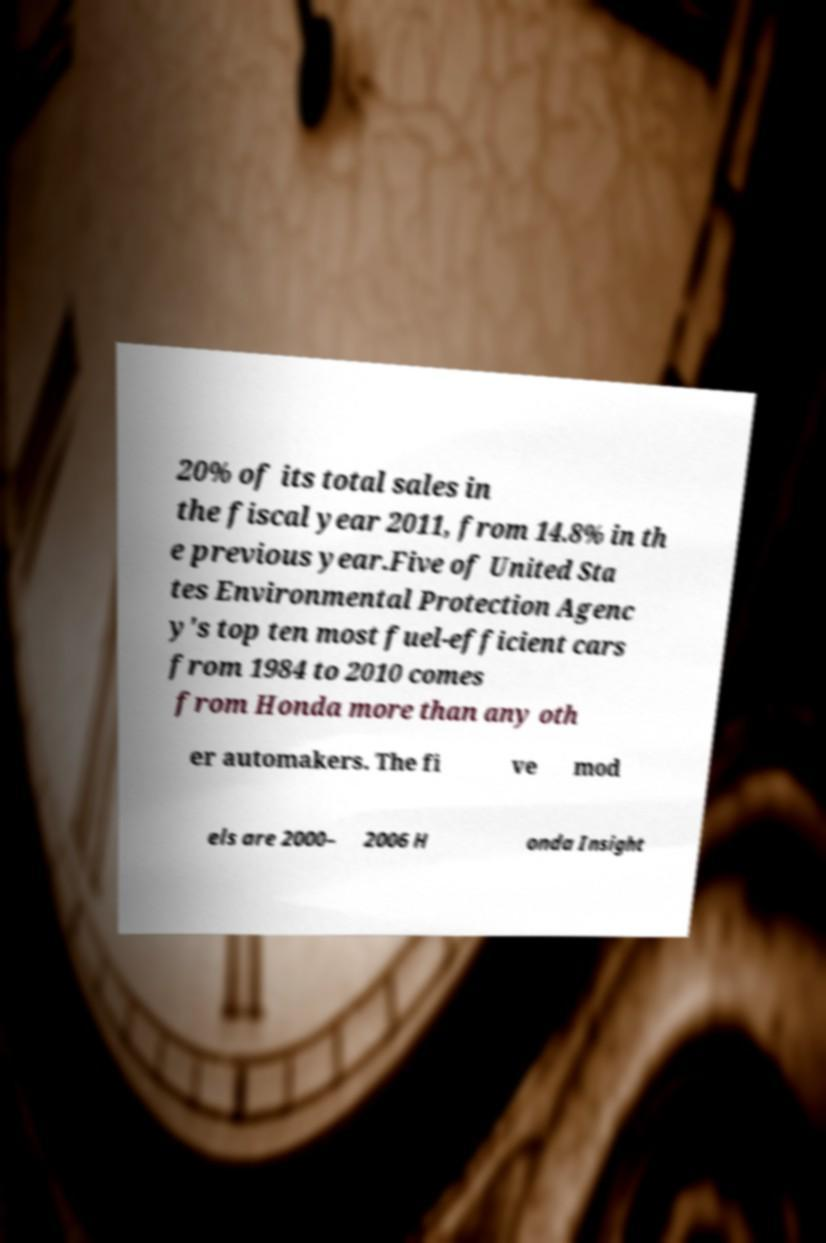Please read and relay the text visible in this image. What does it say? 20% of its total sales in the fiscal year 2011, from 14.8% in th e previous year.Five of United Sta tes Environmental Protection Agenc y's top ten most fuel-efficient cars from 1984 to 2010 comes from Honda more than any oth er automakers. The fi ve mod els are 2000– 2006 H onda Insight 